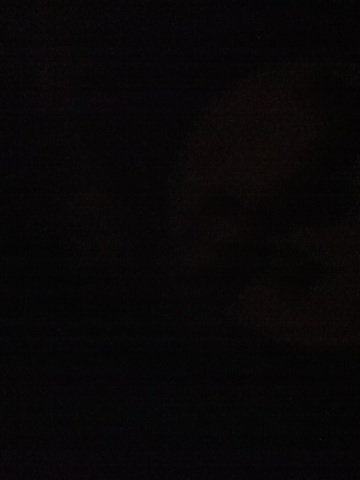What time of day does this image seem to be taken? Given the darkness of the image, it suggests that it might have been taken at night or in a very low-light environment. 